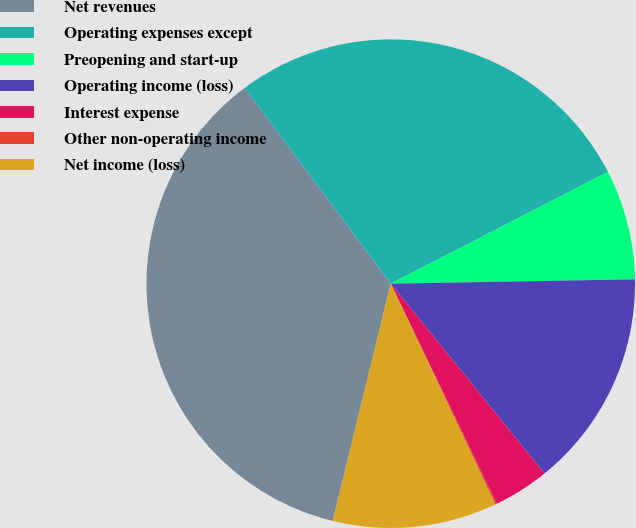<chart> <loc_0><loc_0><loc_500><loc_500><pie_chart><fcel>Net revenues<fcel>Operating expenses except<fcel>Preopening and start-up<fcel>Operating income (loss)<fcel>Interest expense<fcel>Other non-operating income<fcel>Net income (loss)<nl><fcel>35.98%<fcel>27.64%<fcel>7.28%<fcel>14.45%<fcel>3.69%<fcel>0.1%<fcel>10.86%<nl></chart> 